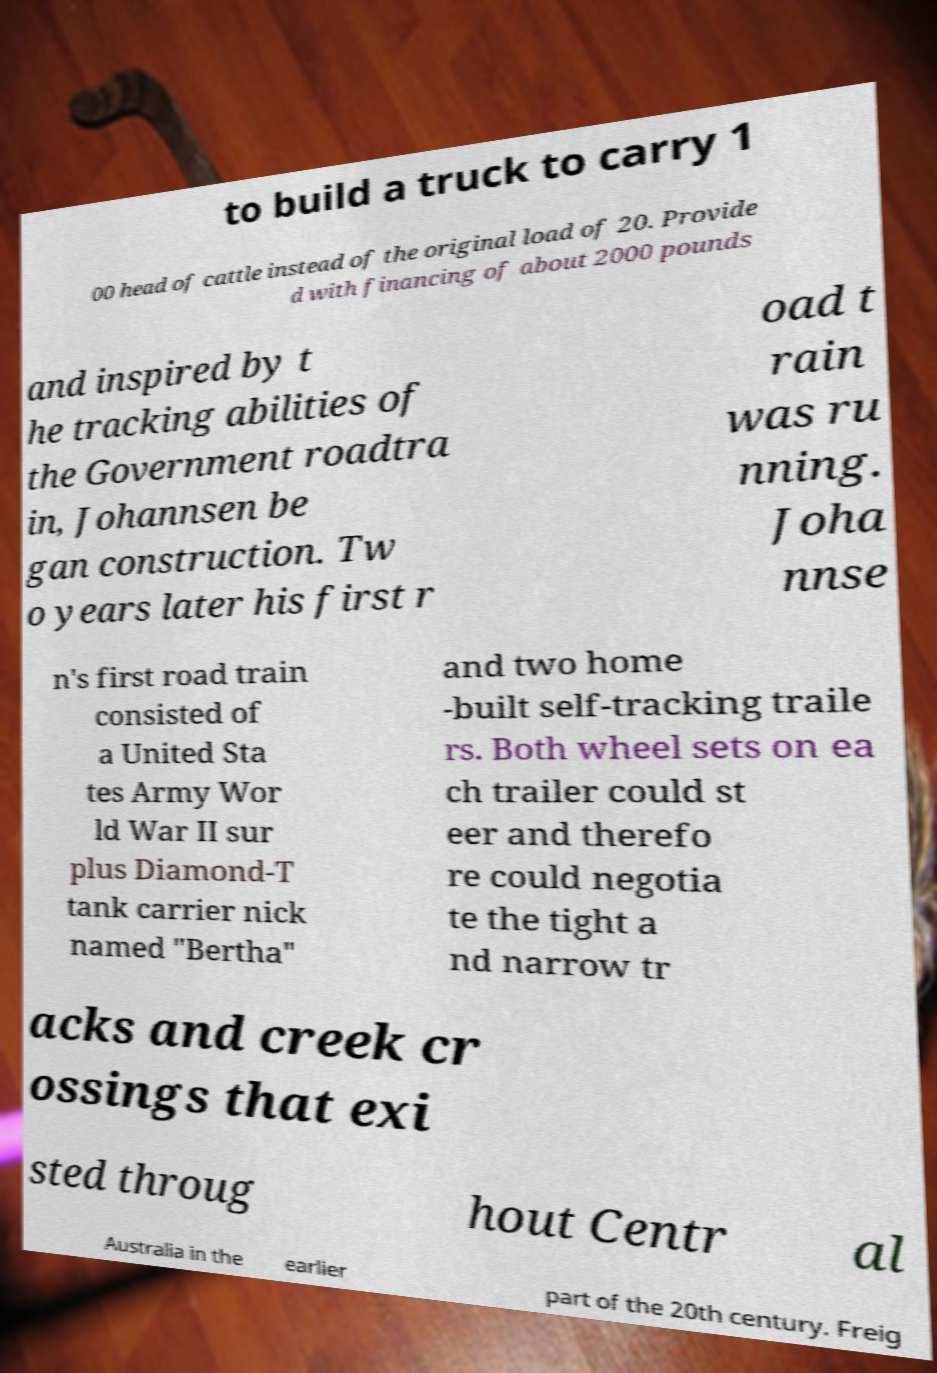What messages or text are displayed in this image? I need them in a readable, typed format. to build a truck to carry 1 00 head of cattle instead of the original load of 20. Provide d with financing of about 2000 pounds and inspired by t he tracking abilities of the Government roadtra in, Johannsen be gan construction. Tw o years later his first r oad t rain was ru nning. Joha nnse n's first road train consisted of a United Sta tes Army Wor ld War II sur plus Diamond-T tank carrier nick named "Bertha" and two home -built self-tracking traile rs. Both wheel sets on ea ch trailer could st eer and therefo re could negotia te the tight a nd narrow tr acks and creek cr ossings that exi sted throug hout Centr al Australia in the earlier part of the 20th century. Freig 